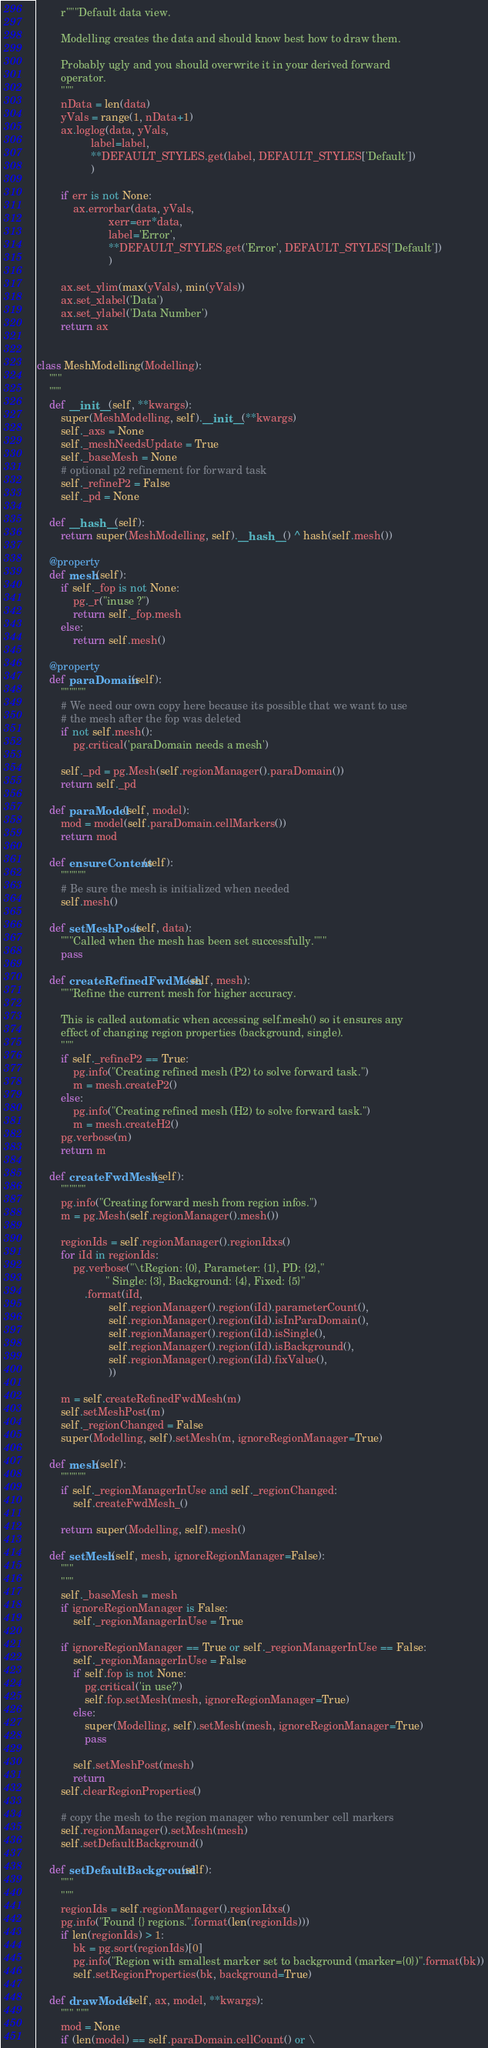<code> <loc_0><loc_0><loc_500><loc_500><_Python_>        r"""Default data view.

        Modelling creates the data and should know best how to draw them.

        Probably ugly and you should overwrite it in your derived forward
        operator.
        """
        nData = len(data)
        yVals = range(1, nData+1)
        ax.loglog(data, yVals,
                  label=label,
                  **DEFAULT_STYLES.get(label, DEFAULT_STYLES['Default'])
                  )

        if err is not None:
            ax.errorbar(data, yVals,
                        xerr=err*data,
                        label='Error',
                        **DEFAULT_STYLES.get('Error', DEFAULT_STYLES['Default'])
                        )

        ax.set_ylim(max(yVals), min(yVals))
        ax.set_xlabel('Data')
        ax.set_ylabel('Data Number')
        return ax


class MeshModelling(Modelling):
    """
    """
    def __init__(self, **kwargs):
        super(MeshModelling, self).__init__(**kwargs)
        self._axs = None
        self._meshNeedsUpdate = True
        self._baseMesh = None
        # optional p2 refinement for forward task
        self._refineP2 = False
        self._pd = None

    def __hash__(self):
        return super(MeshModelling, self).__hash__() ^ hash(self.mesh())

    @property
    def mesh(self):
        if self._fop is not None:
            pg._r("inuse ?")
            return self._fop.mesh
        else:
            return self.mesh()

    @property
    def paraDomain(self):
        """"""
        # We need our own copy here because its possible that we want to use
        # the mesh after the fop was deleted
        if not self.mesh():
            pg.critical('paraDomain needs a mesh')

        self._pd = pg.Mesh(self.regionManager().paraDomain())
        return self._pd

    def paraModel(self, model):
        mod = model(self.paraDomain.cellMarkers())
        return mod

    def ensureContent(self):
        """"""
        # Be sure the mesh is initialized when needed
        self.mesh()

    def setMeshPost(self, data):
        """Called when the mesh has been set successfully."""
        pass

    def createRefinedFwdMesh(self, mesh):
        """Refine the current mesh for higher accuracy.

        This is called automatic when accessing self.mesh() so it ensures any
        effect of changing region properties (background, single).
        """
        if self._refineP2 == True:
            pg.info("Creating refined mesh (P2) to solve forward task.")
            m = mesh.createP2()
        else:
            pg.info("Creating refined mesh (H2) to solve forward task.")
            m = mesh.createH2()
        pg.verbose(m)
        return m

    def createFwdMesh_(self):
        """"""
        pg.info("Creating forward mesh from region infos.")
        m = pg.Mesh(self.regionManager().mesh())

        regionIds = self.regionManager().regionIdxs()
        for iId in regionIds:
            pg.verbose("\tRegion: {0}, Parameter: {1}, PD: {2},"
                       " Single: {3}, Background: {4}, Fixed: {5}"
                .format(iId,
                        self.regionManager().region(iId).parameterCount(),
                        self.regionManager().region(iId).isInParaDomain(),
                        self.regionManager().region(iId).isSingle(),
                        self.regionManager().region(iId).isBackground(),
                        self.regionManager().region(iId).fixValue(),
                        ))

        m = self.createRefinedFwdMesh(m)
        self.setMeshPost(m)
        self._regionChanged = False
        super(Modelling, self).setMesh(m, ignoreRegionManager=True)

    def mesh(self):
        """"""
        if self._regionManagerInUse and self._regionChanged:
            self.createFwdMesh_()

        return super(Modelling, self).mesh()

    def setMesh(self, mesh, ignoreRegionManager=False):
        """
        """
        self._baseMesh = mesh
        if ignoreRegionManager is False:
            self._regionManagerInUse = True

        if ignoreRegionManager == True or self._regionManagerInUse == False:
            self._regionManagerInUse = False
            if self.fop is not None:
                pg.critical('in use?')
                self.fop.setMesh(mesh, ignoreRegionManager=True)
            else:
                super(Modelling, self).setMesh(mesh, ignoreRegionManager=True)
                pass

            self.setMeshPost(mesh)
            return
        self.clearRegionProperties()

        # copy the mesh to the region manager who renumber cell markers
        self.regionManager().setMesh(mesh)
        self.setDefaultBackground()

    def setDefaultBackground(self):
        """
        """
        regionIds = self.regionManager().regionIdxs()
        pg.info("Found {} regions.".format(len(regionIds)))
        if len(regionIds) > 1:
            bk = pg.sort(regionIds)[0]
            pg.info("Region with smallest marker set to background (marker={0})".format(bk))
            self.setRegionProperties(bk, background=True)

    def drawModel(self, ax, model, **kwargs):
        """ """
        mod = None
        if (len(model) == self.paraDomain.cellCount() or \</code> 